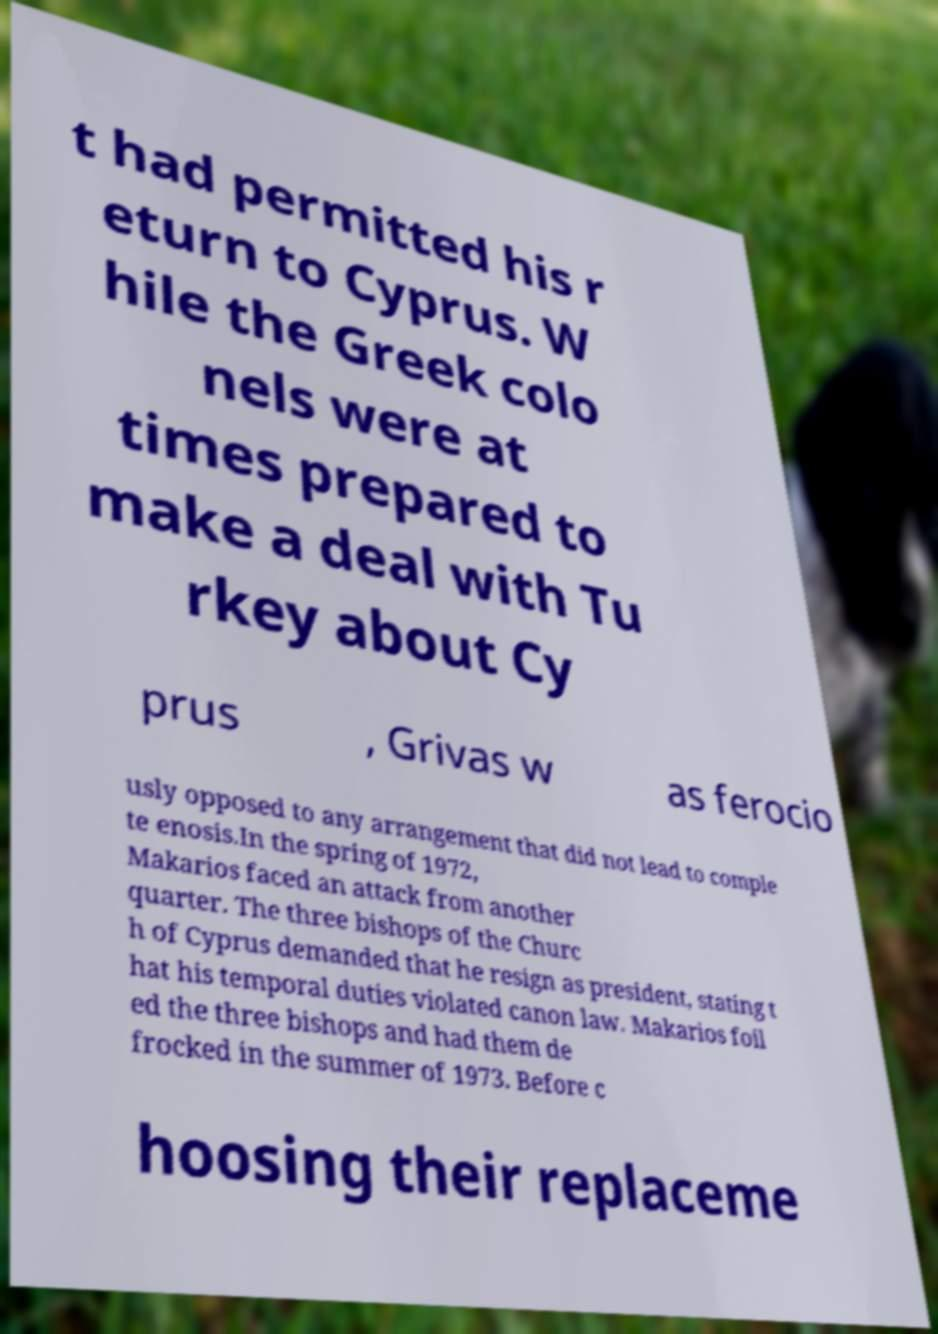Please read and relay the text visible in this image. What does it say? t had permitted his r eturn to Cyprus. W hile the Greek colo nels were at times prepared to make a deal with Tu rkey about Cy prus , Grivas w as ferocio usly opposed to any arrangement that did not lead to comple te enosis.In the spring of 1972, Makarios faced an attack from another quarter. The three bishops of the Churc h of Cyprus demanded that he resign as president, stating t hat his temporal duties violated canon law. Makarios foil ed the three bishops and had them de frocked in the summer of 1973. Before c hoosing their replaceme 